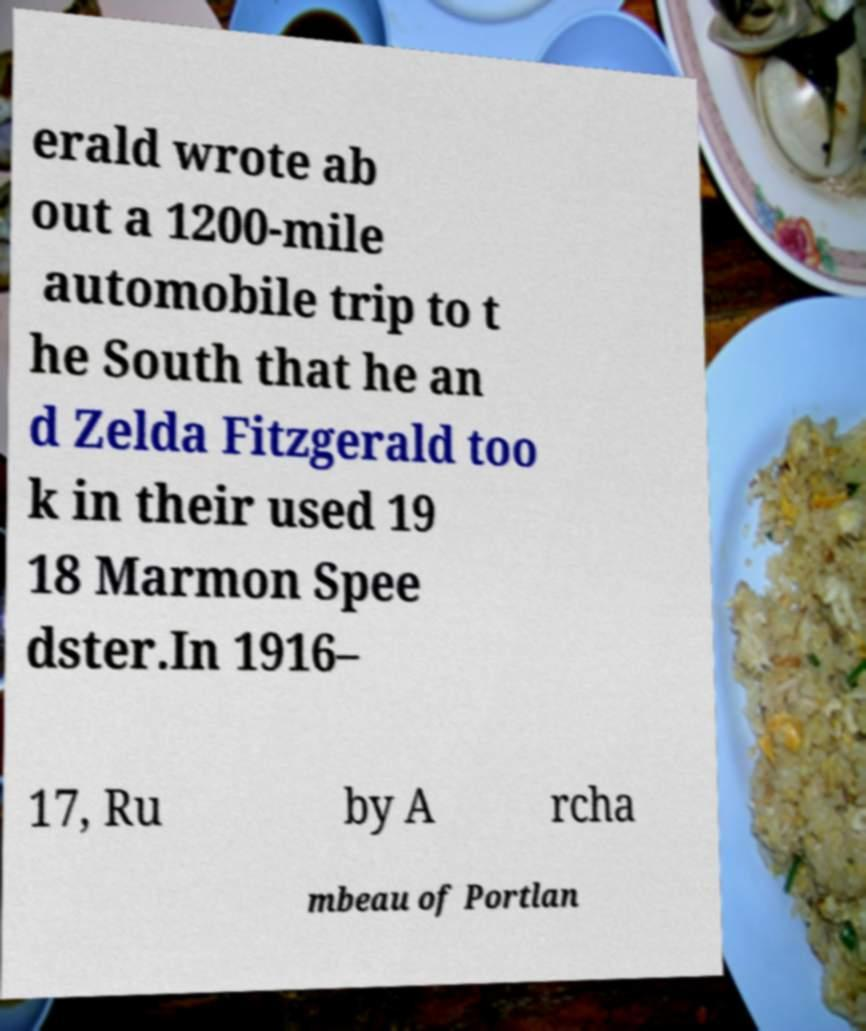I need the written content from this picture converted into text. Can you do that? erald wrote ab out a 1200-mile automobile trip to t he South that he an d Zelda Fitzgerald too k in their used 19 18 Marmon Spee dster.In 1916– 17, Ru by A rcha mbeau of Portlan 